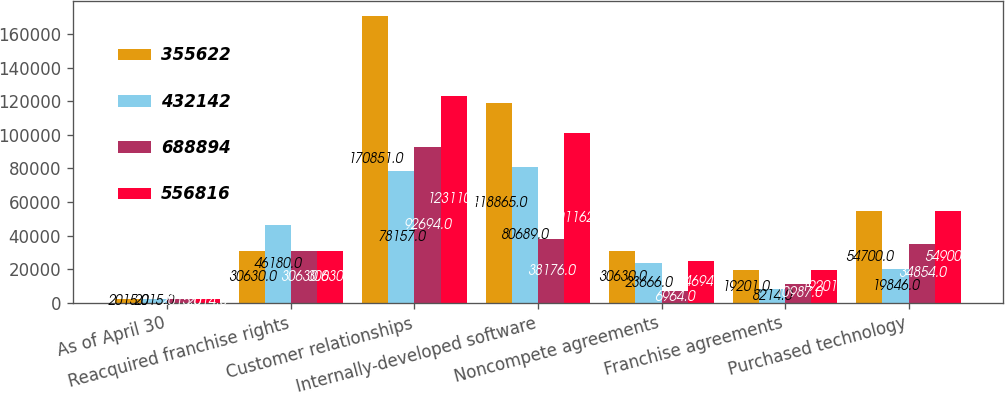Convert chart. <chart><loc_0><loc_0><loc_500><loc_500><stacked_bar_chart><ecel><fcel>As of April 30<fcel>Reacquired franchise rights<fcel>Customer relationships<fcel>Internally-developed software<fcel>Noncompete agreements<fcel>Franchise agreements<fcel>Purchased technology<nl><fcel>355622<fcel>2015<fcel>30630<fcel>170851<fcel>118865<fcel>30630<fcel>19201<fcel>54700<nl><fcel>432142<fcel>2015<fcel>46180<fcel>78157<fcel>80689<fcel>23666<fcel>8214<fcel>19846<nl><fcel>688894<fcel>2015<fcel>30630<fcel>92694<fcel>38176<fcel>6964<fcel>10987<fcel>34854<nl><fcel>556816<fcel>2014<fcel>30630<fcel>123110<fcel>101162<fcel>24694<fcel>19201<fcel>54900<nl></chart> 